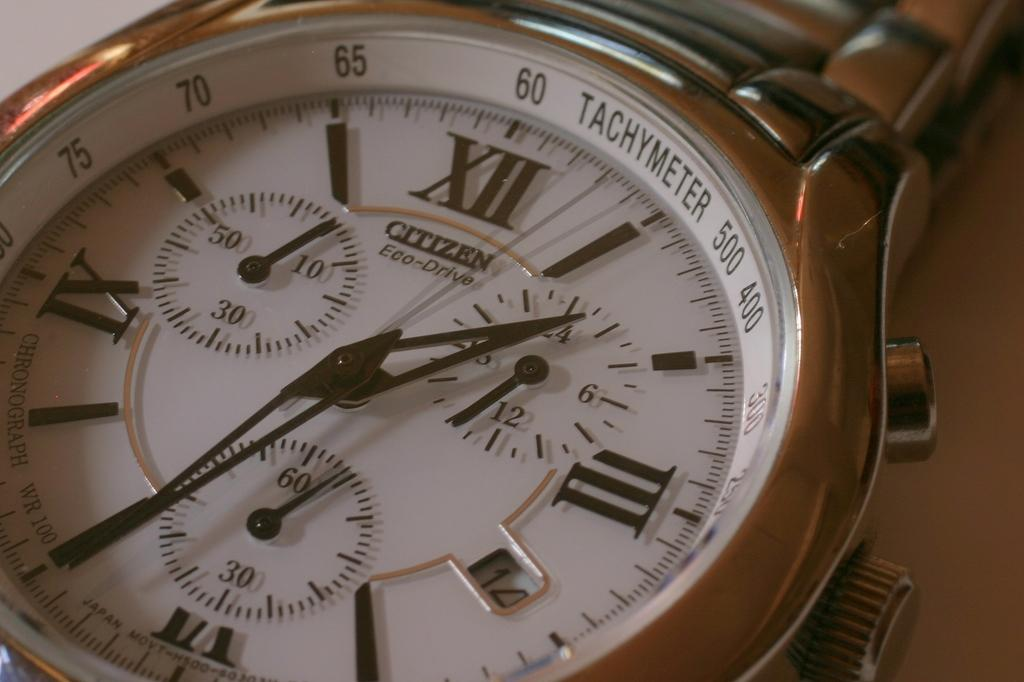Provide a one-sentence caption for the provided image. A close up of the face of a Citizen brand watch. 